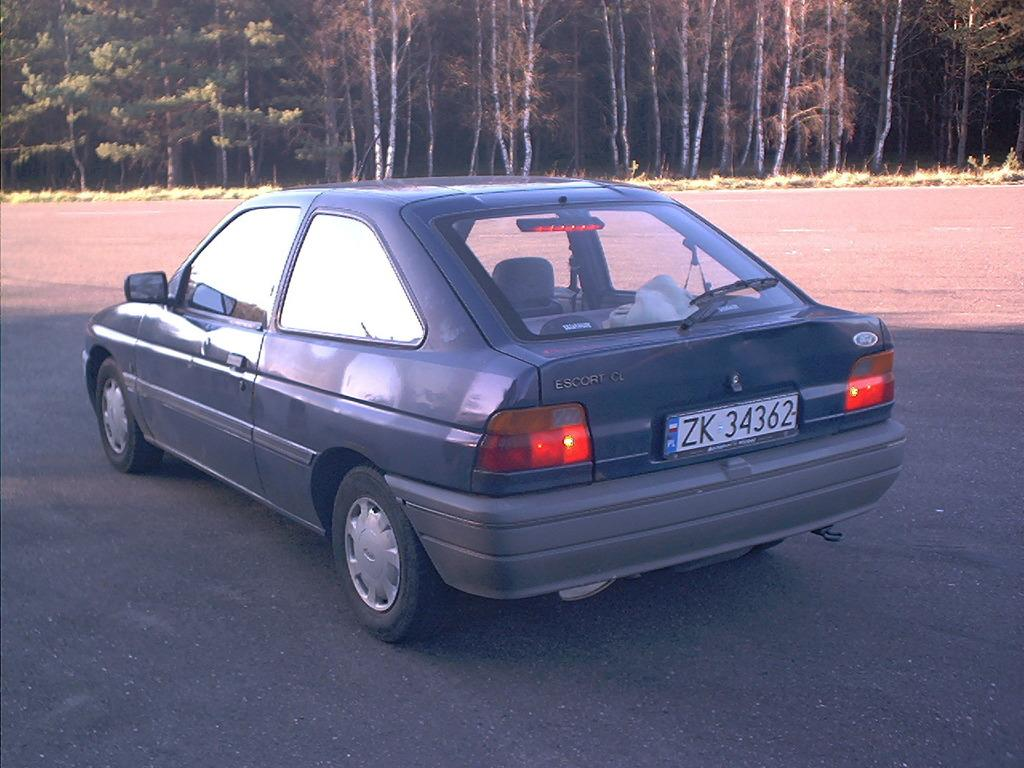What is the main subject of the image? There is a car in the image. What can be seen in the background of the image? There are trees in the background of the image. What type of plantation is visible in the image? There is no plantation present in the image; it features a car and trees in the background. Can you see any pipes in the image? There are no pipes visible in the image. 